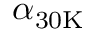<formula> <loc_0><loc_0><loc_500><loc_500>\alpha _ { 3 0 K }</formula> 